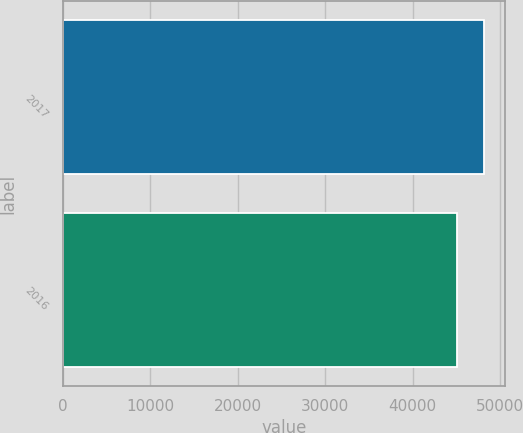Convert chart to OTSL. <chart><loc_0><loc_0><loc_500><loc_500><bar_chart><fcel>2017<fcel>2016<nl><fcel>48151<fcel>45080<nl></chart> 